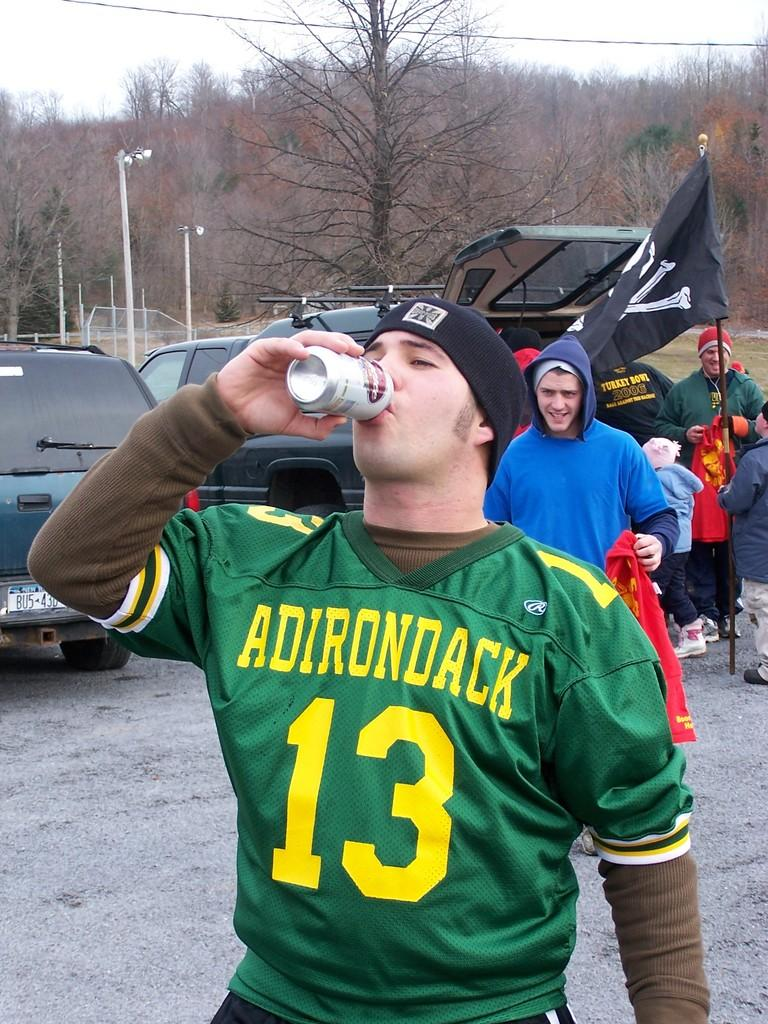<image>
Relay a brief, clear account of the picture shown. A man wearing an Adirondack jersey number 13 drinks out of a can in front of some parked cars. 